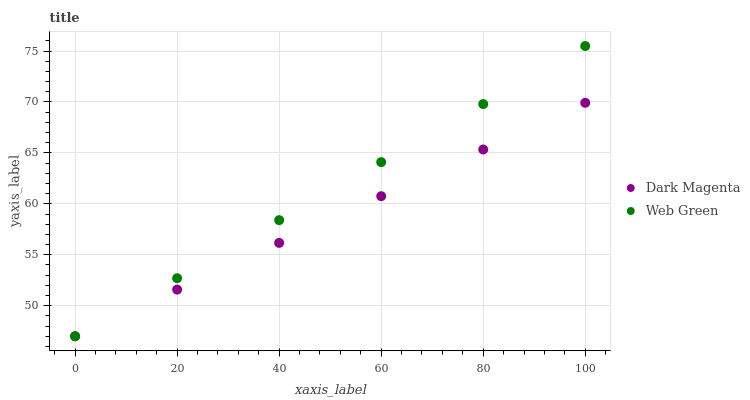Does Dark Magenta have the minimum area under the curve?
Answer yes or no. Yes. Does Web Green have the maximum area under the curve?
Answer yes or no. Yes. Does Web Green have the minimum area under the curve?
Answer yes or no. No. Is Web Green the smoothest?
Answer yes or no. Yes. Is Dark Magenta the roughest?
Answer yes or no. Yes. Is Web Green the roughest?
Answer yes or no. No. Does Dark Magenta have the lowest value?
Answer yes or no. Yes. Does Web Green have the highest value?
Answer yes or no. Yes. Does Web Green intersect Dark Magenta?
Answer yes or no. Yes. Is Web Green less than Dark Magenta?
Answer yes or no. No. Is Web Green greater than Dark Magenta?
Answer yes or no. No. 